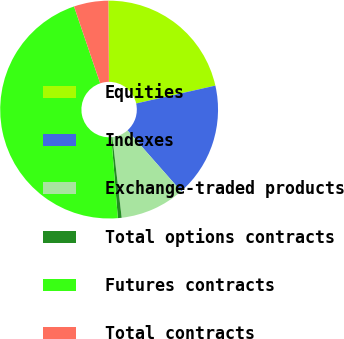<chart> <loc_0><loc_0><loc_500><loc_500><pie_chart><fcel>Equities<fcel>Indexes<fcel>Exchange-traded products<fcel>Total options contracts<fcel>Futures contracts<fcel>Total contracts<nl><fcel>21.58%<fcel>17.03%<fcel>9.66%<fcel>0.56%<fcel>46.06%<fcel>5.11%<nl></chart> 